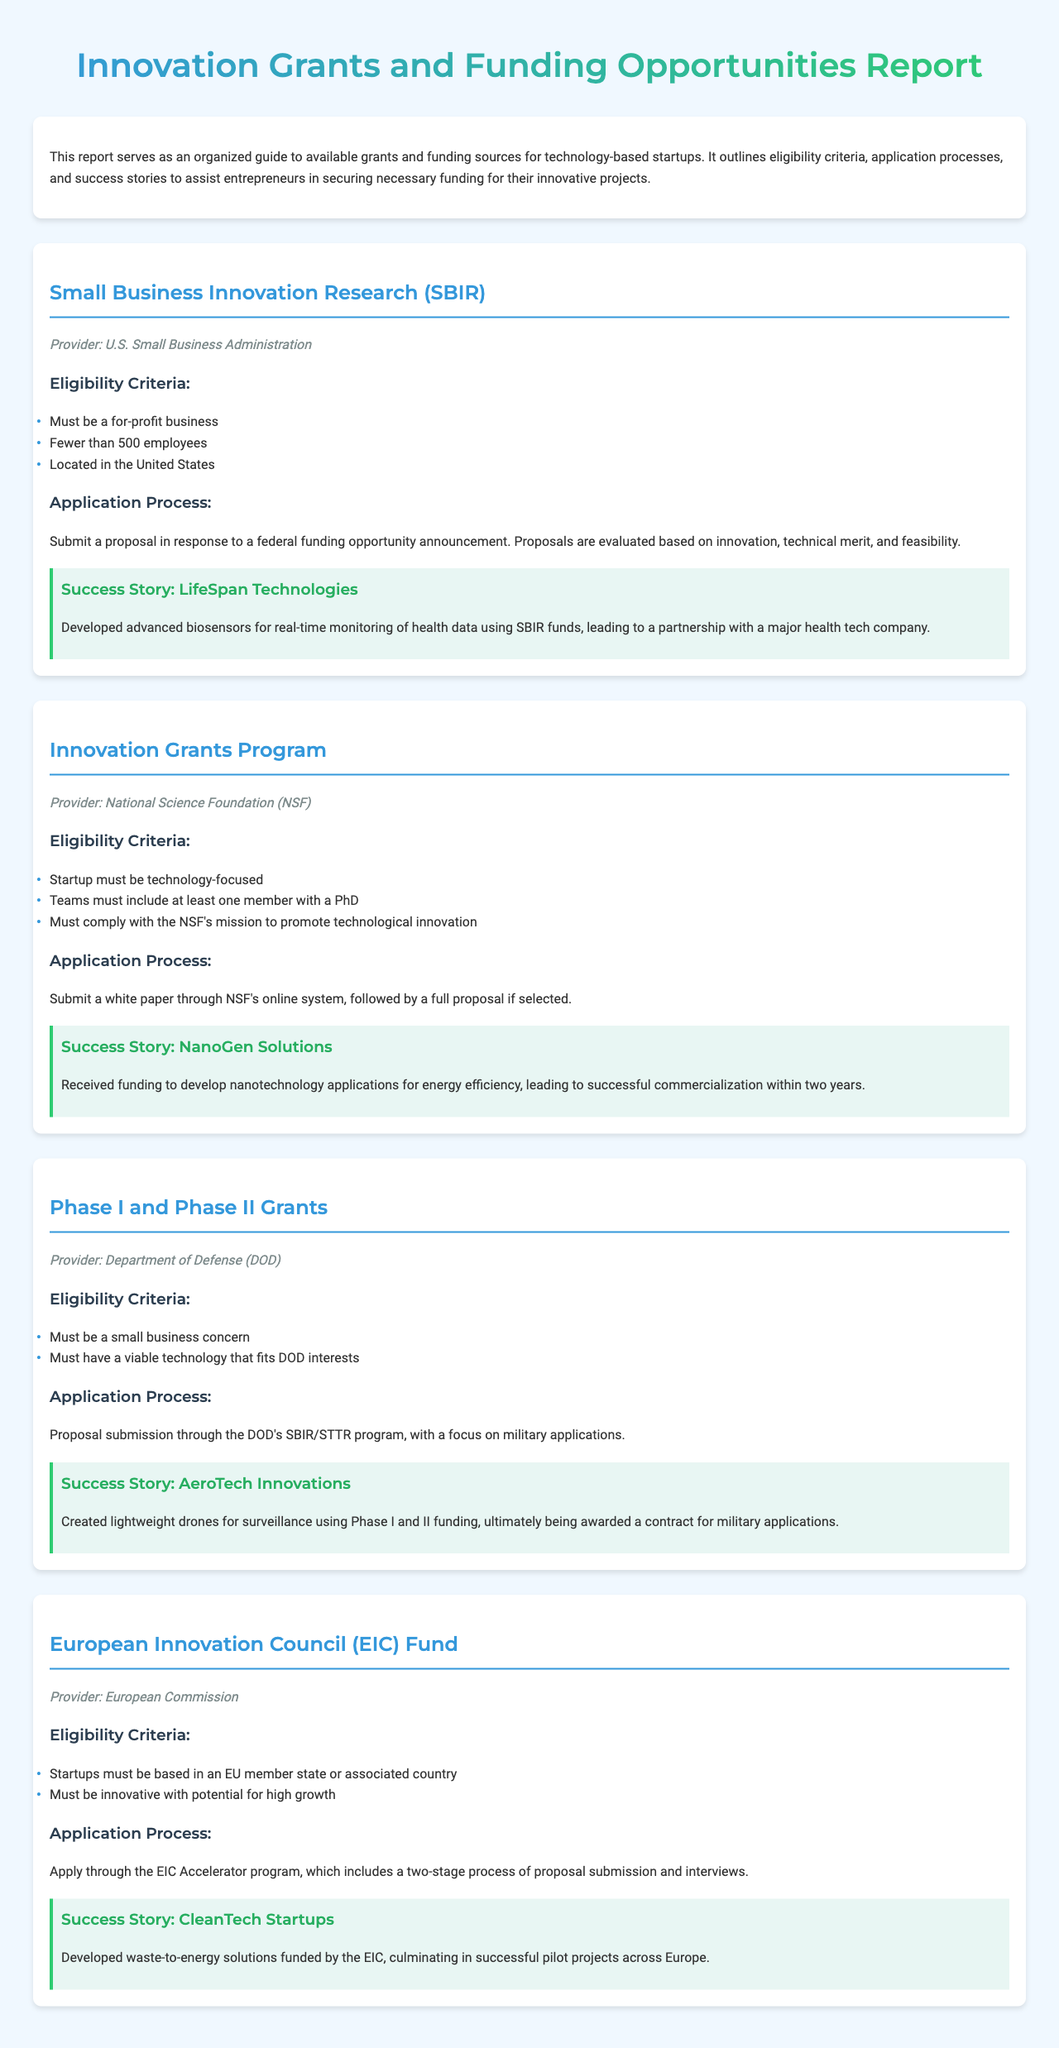What is the title of the report? The title of the report is presented prominently at the top of the document.
Answer: Innovation Grants and Funding Opportunities Report Who provides the Small Business Innovation Research? The document specifies the provider of this funding opportunity.
Answer: U.S. Small Business Administration What is the eligibility criterion for the Innovation Grants Program? The eligibility criteria for the program are listed in the document, specifically for startups.
Answer: Startup must be technology-focused How many employees must a business have to be eligible for SBIR? The eligibility criteria state a specific employee limit for SBIR participants.
Answer: Fewer than 500 employees What is required in the application process for the European Innovation Council Fund? The document describes the general steps for applying to this fund.
Answer: Apply through the EIC Accelerator program What was developed using SBIR funds by LifeSpan Technologies? The success story gives a specific example of the outcome for LifeSpan Technologies.
Answer: Advanced biosensors Which startup received funding to develop nanotechnology applications? The document includes the name of a startup related to nanotechnology funding success.
Answer: NanoGen Solutions What is a common feature of the application processes mentioned in the report? The document indicates a pattern in how applications are submitted across different funding opportunities.
Answer: Proposal submission What is the success story for CleanTech Startups? The document details a notable achievement related to funding for CleanTech Startups.
Answer: Developed waste-to-energy solutions 